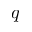<formula> <loc_0><loc_0><loc_500><loc_500>q</formula> 